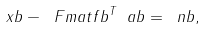Convert formula to latex. <formula><loc_0><loc_0><loc_500><loc_500>\ x b - \ F m a t f b ^ { T } \ a b = \ n b ,</formula> 